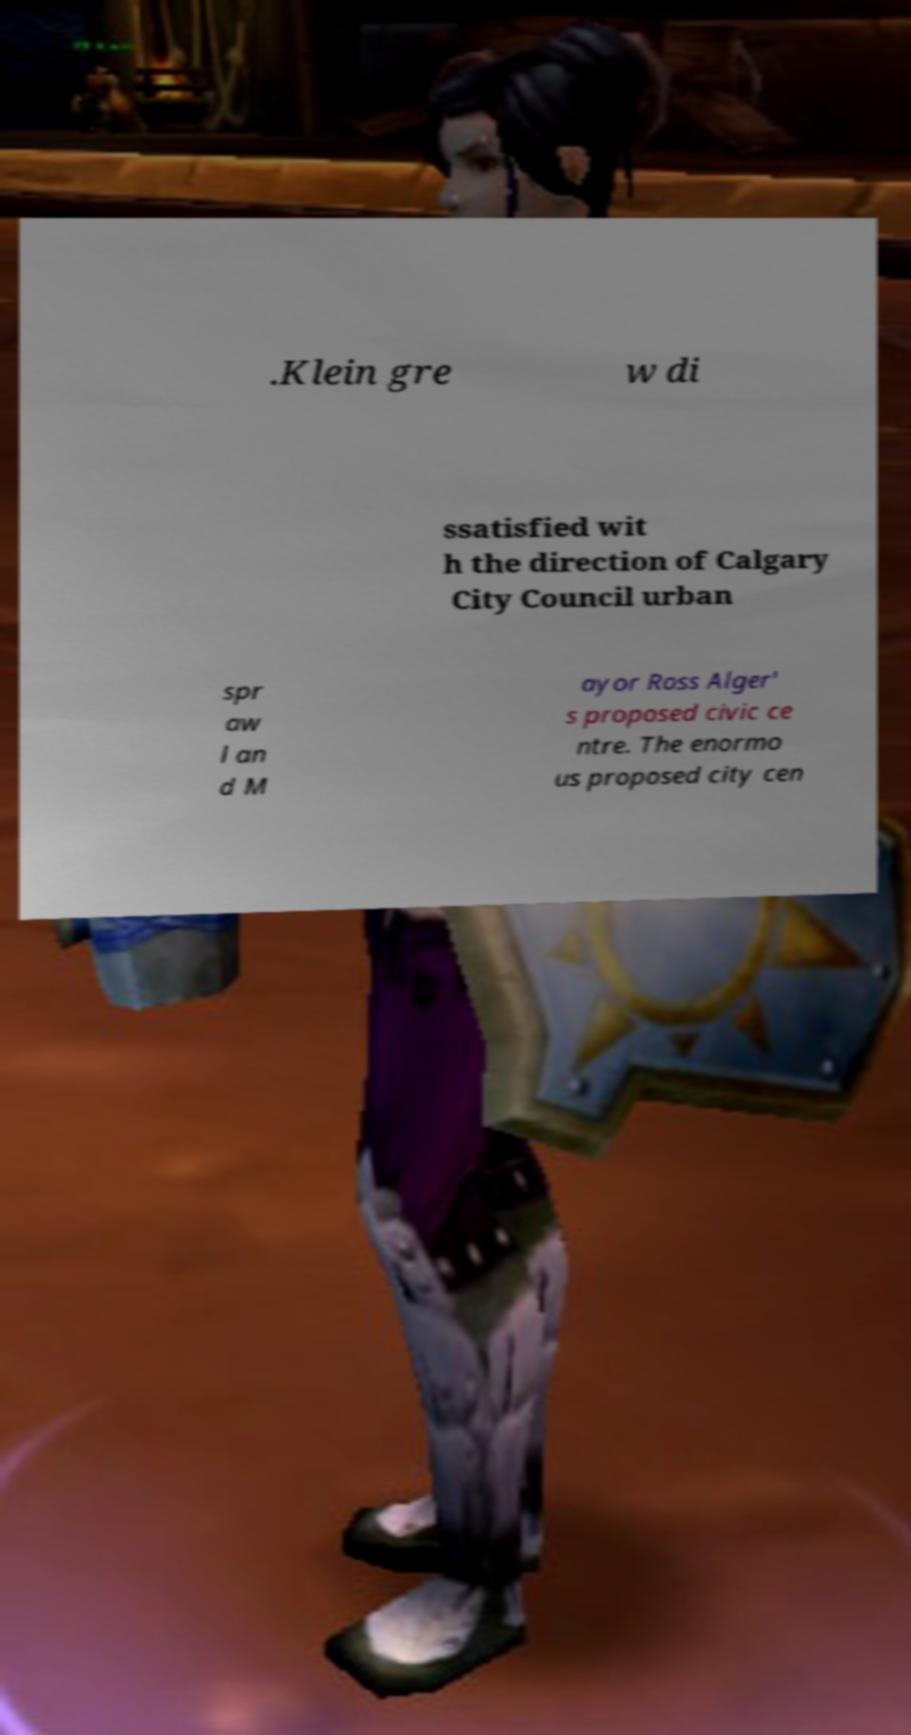Can you read and provide the text displayed in the image?This photo seems to have some interesting text. Can you extract and type it out for me? .Klein gre w di ssatisfied wit h the direction of Calgary City Council urban spr aw l an d M ayor Ross Alger' s proposed civic ce ntre. The enormo us proposed city cen 